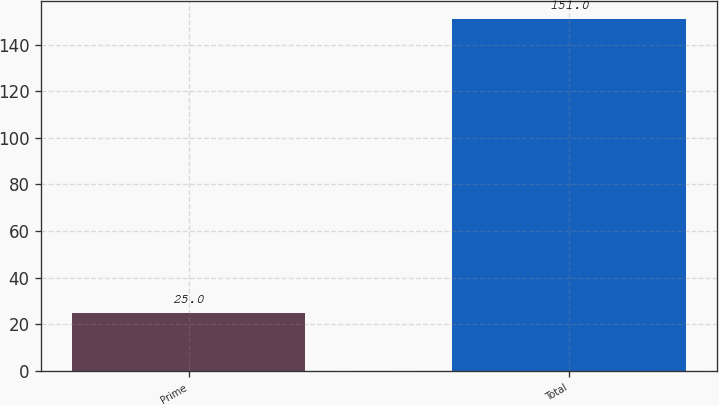Convert chart to OTSL. <chart><loc_0><loc_0><loc_500><loc_500><bar_chart><fcel>Prime<fcel>Total<nl><fcel>25<fcel>151<nl></chart> 